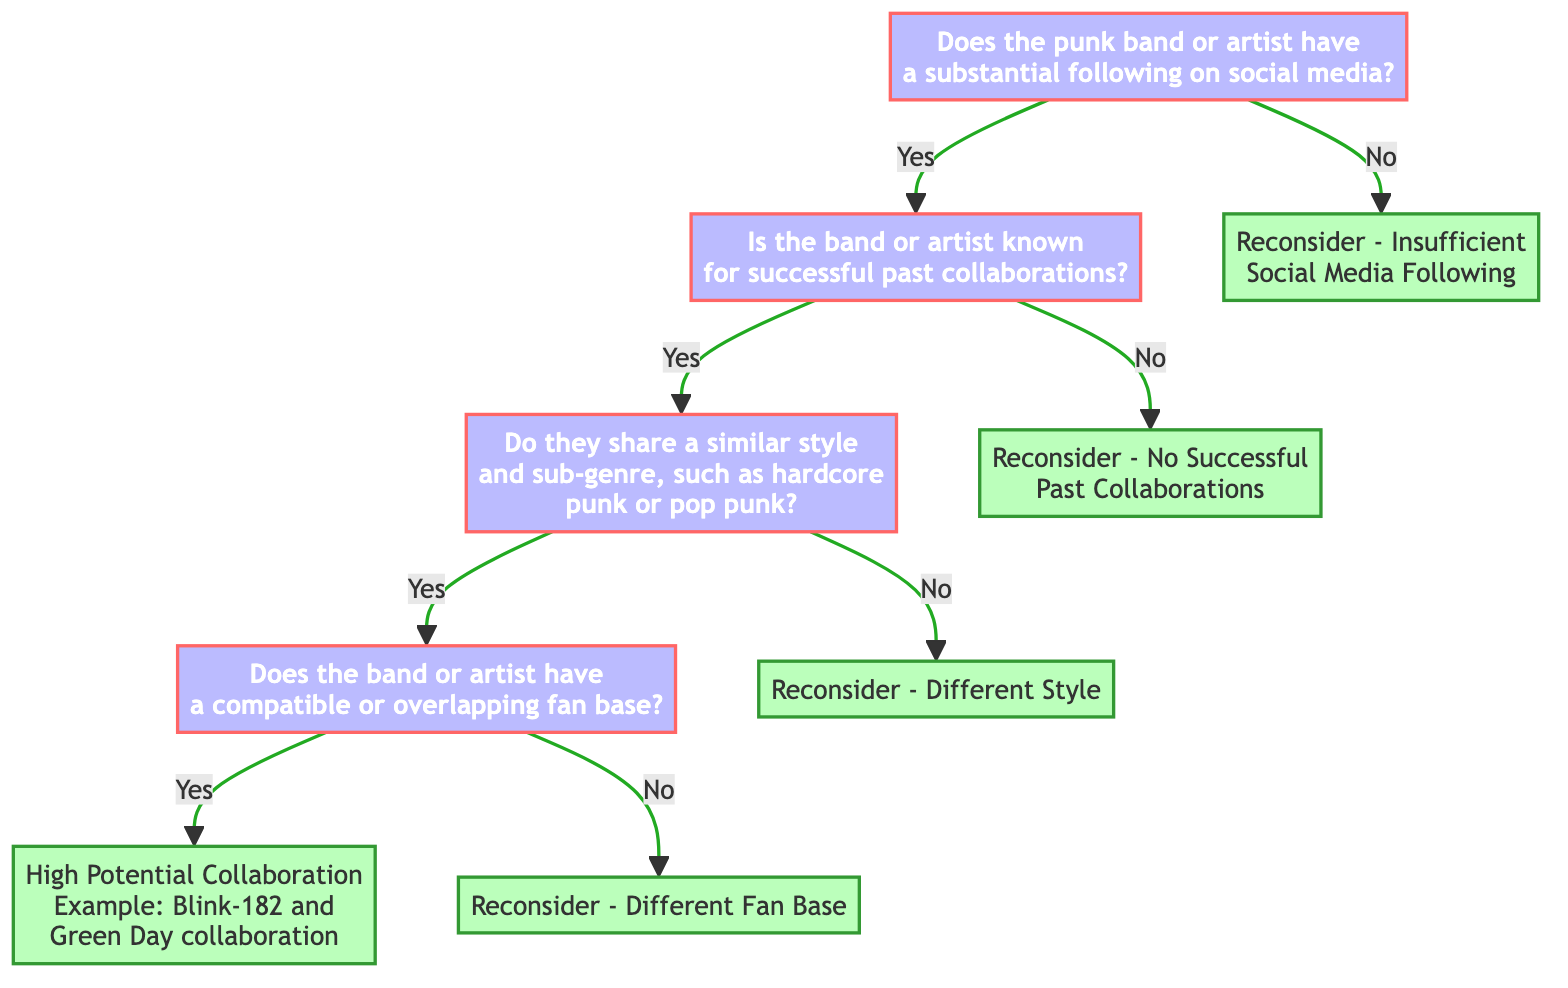Does the decision tree start with a question about social media following? The decision tree initiates with the question, "Does the punk band or artist have a substantial following on social media?" This is the first node and sets the context for all subsequent decisions.
Answer: Yes How many main decision nodes are there in the diagram? The diagram consists of three main decision nodes: one asking about social media following, one regarding past collaborations, and another concerning style and sub-genre. These nodes determine the path through the tree.
Answer: Three What happens if a band has no substantial following on social media? If the answer to the initial question about social media following is "No," the decision tree leads to the endpoint "Reconsider - Insufficient Social Media Following," indicating that the band should not pursue collaboration opportunities.
Answer: Reconsider - Insufficient Social Media Following What is the outcome if the band has a similar style and an overlapping fan base? If both the style and fan base are confirmed as compatible (answering "Yes" to both respective questions), the outcome is "High Potential Collaboration" with an example of a collaboration between Blink-182 and Green Day.
Answer: High Potential Collaboration What does the tree suggest if the band has had no successful past collaborations? If the response to the question about successful past collaborations is "No," the decision leads to the endpoint "Reconsider - No Successful Past Collaborations," suggesting a lack of viability for collaboration.
Answer: Reconsider - No Successful Past Collaborations What does the decision tree indicate when the styles differ? If it is determined that the band or artist does not share a similar style and sub-genre, the tree indicates the endpoint "Reconsider - Different Style," meaning that collaboration is not advisable.
Answer: Reconsider - Different Style Is the final decision node regarding a high potential collaboration? The final decision node can actually lead to multiple endpoints; however, "High Potential Collaboration" is one of them, which indicates a successful synergy and potential partnership.
Answer: Yes What action should be taken if the fan bases do not overlap? If it is determined that there is no compatible or overlapping fan base after confirming style, the recommendation from the tree is to "Reconsider - Different Fan Base," suggesting collaboration isn't feasible.
Answer: Reconsider - Different Fan Base 